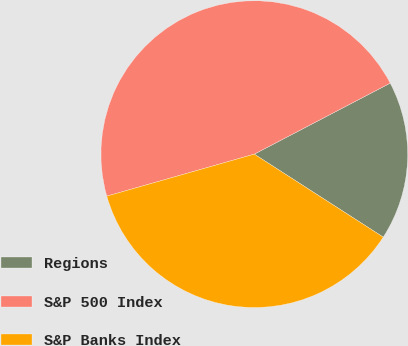<chart> <loc_0><loc_0><loc_500><loc_500><pie_chart><fcel>Regions<fcel>S&P 500 Index<fcel>S&P Banks Index<nl><fcel>16.76%<fcel>46.75%<fcel>36.48%<nl></chart> 